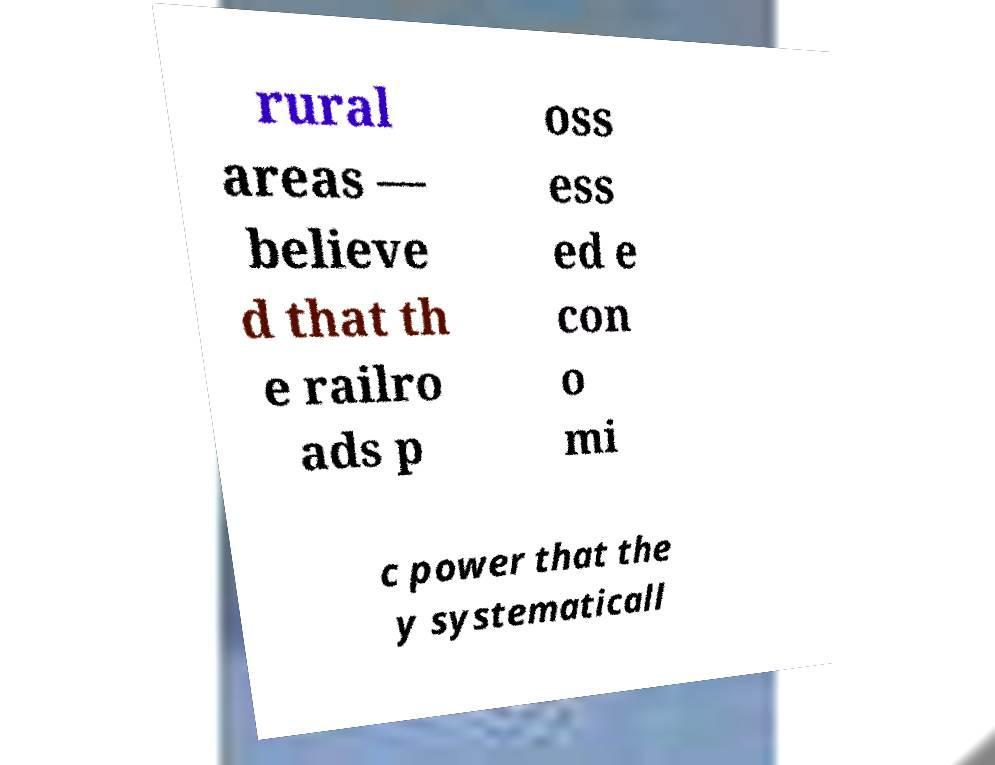Can you read and provide the text displayed in the image?This photo seems to have some interesting text. Can you extract and type it out for me? rural areas — believe d that th e railro ads p oss ess ed e con o mi c power that the y systematicall 